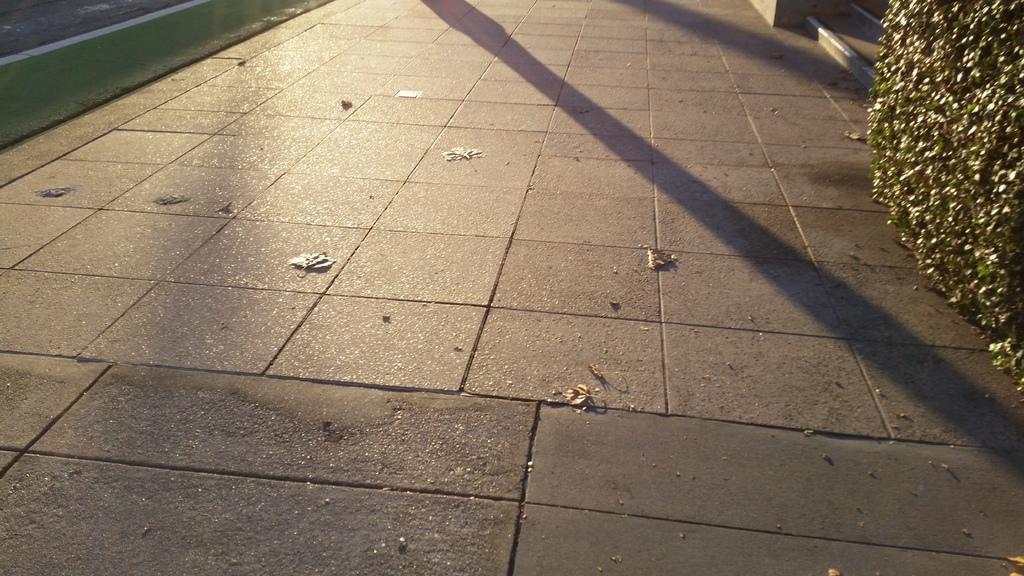Please provide a concise description of this image. In this image there is a floor on which we can see that there are few leaves. On the right side top there is a plant, Beside the plant there are steps. On the left side top there is a road. 